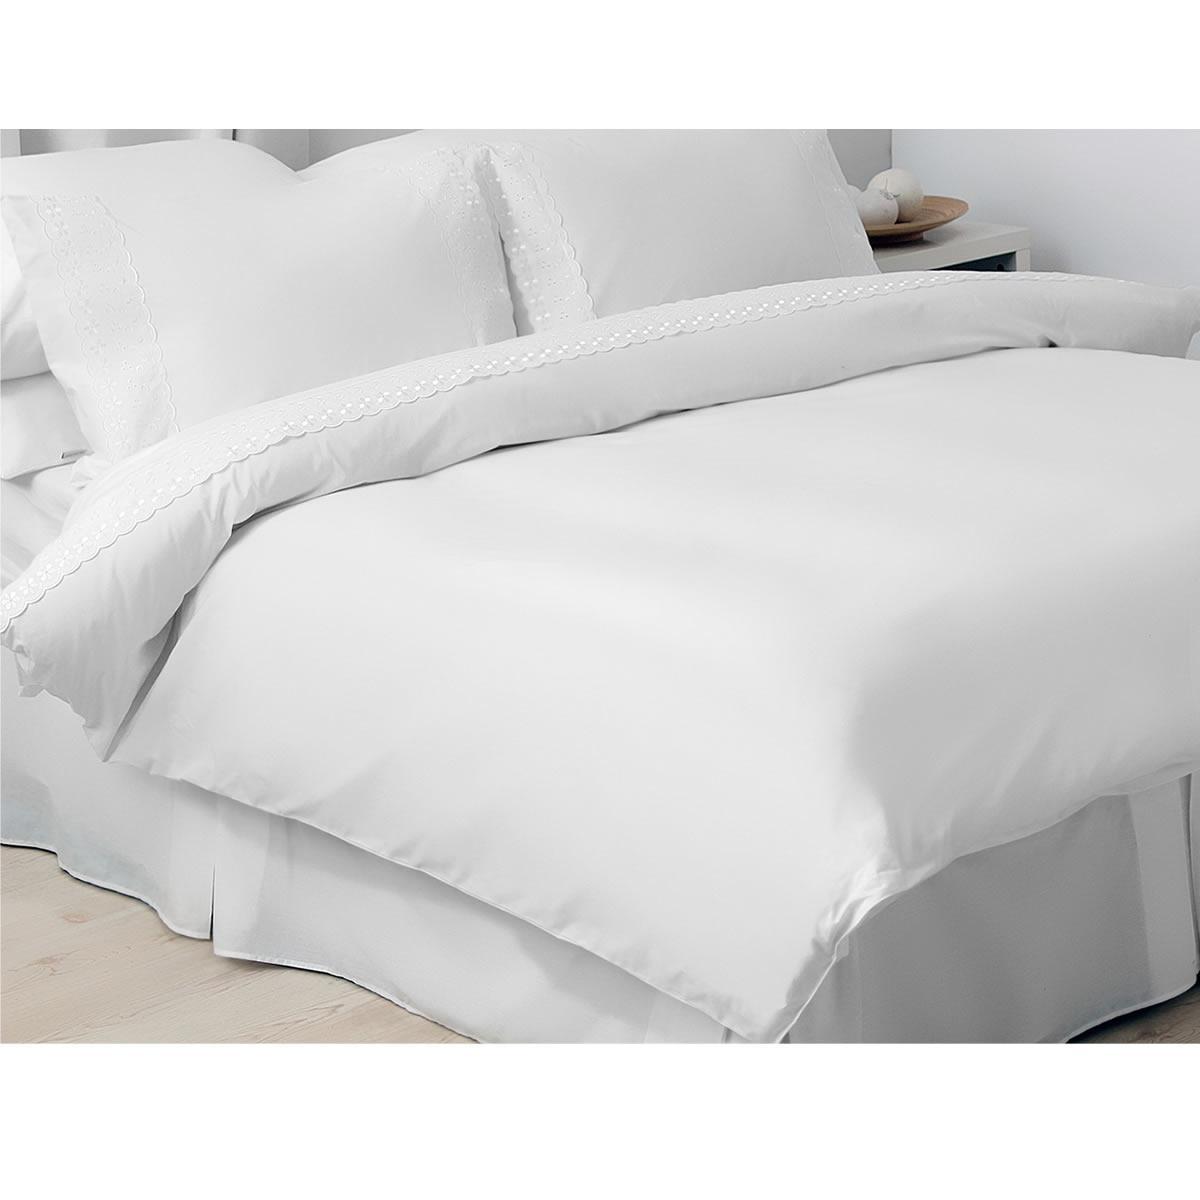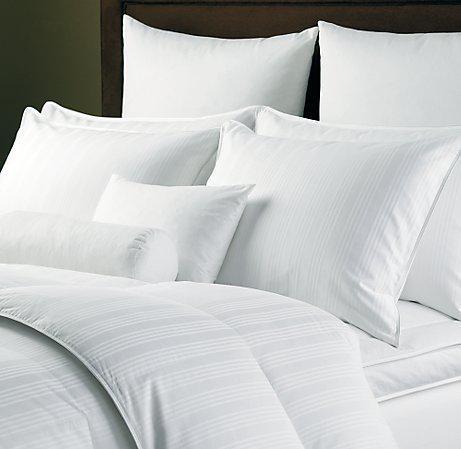The first image is the image on the left, the second image is the image on the right. Considering the images on both sides, is "Each image shows a bed with white bedding and white pillows, and one image shows a long narrow pillow in front of at least four taller rectangular pillows." valid? Answer yes or no. Yes. The first image is the image on the left, the second image is the image on the right. For the images shown, is this caption "The left and right images both show white pillows on a bed with all white bedding." true? Answer yes or no. Yes. 